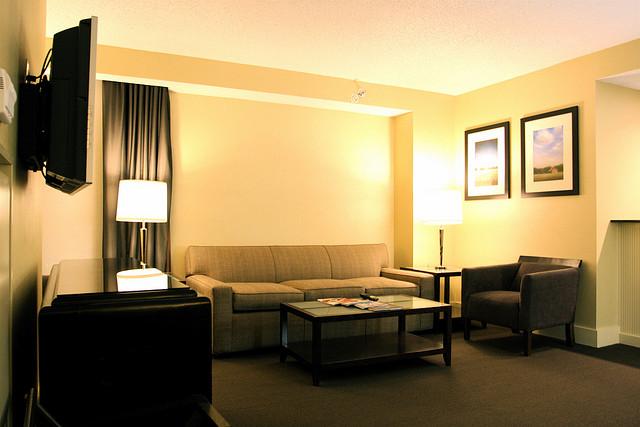Is there a television?
Keep it brief. Yes. What is on the wall below the ceiling?
Concise answer only. Tv. Is this a LED television?
Answer briefly. Yes. 